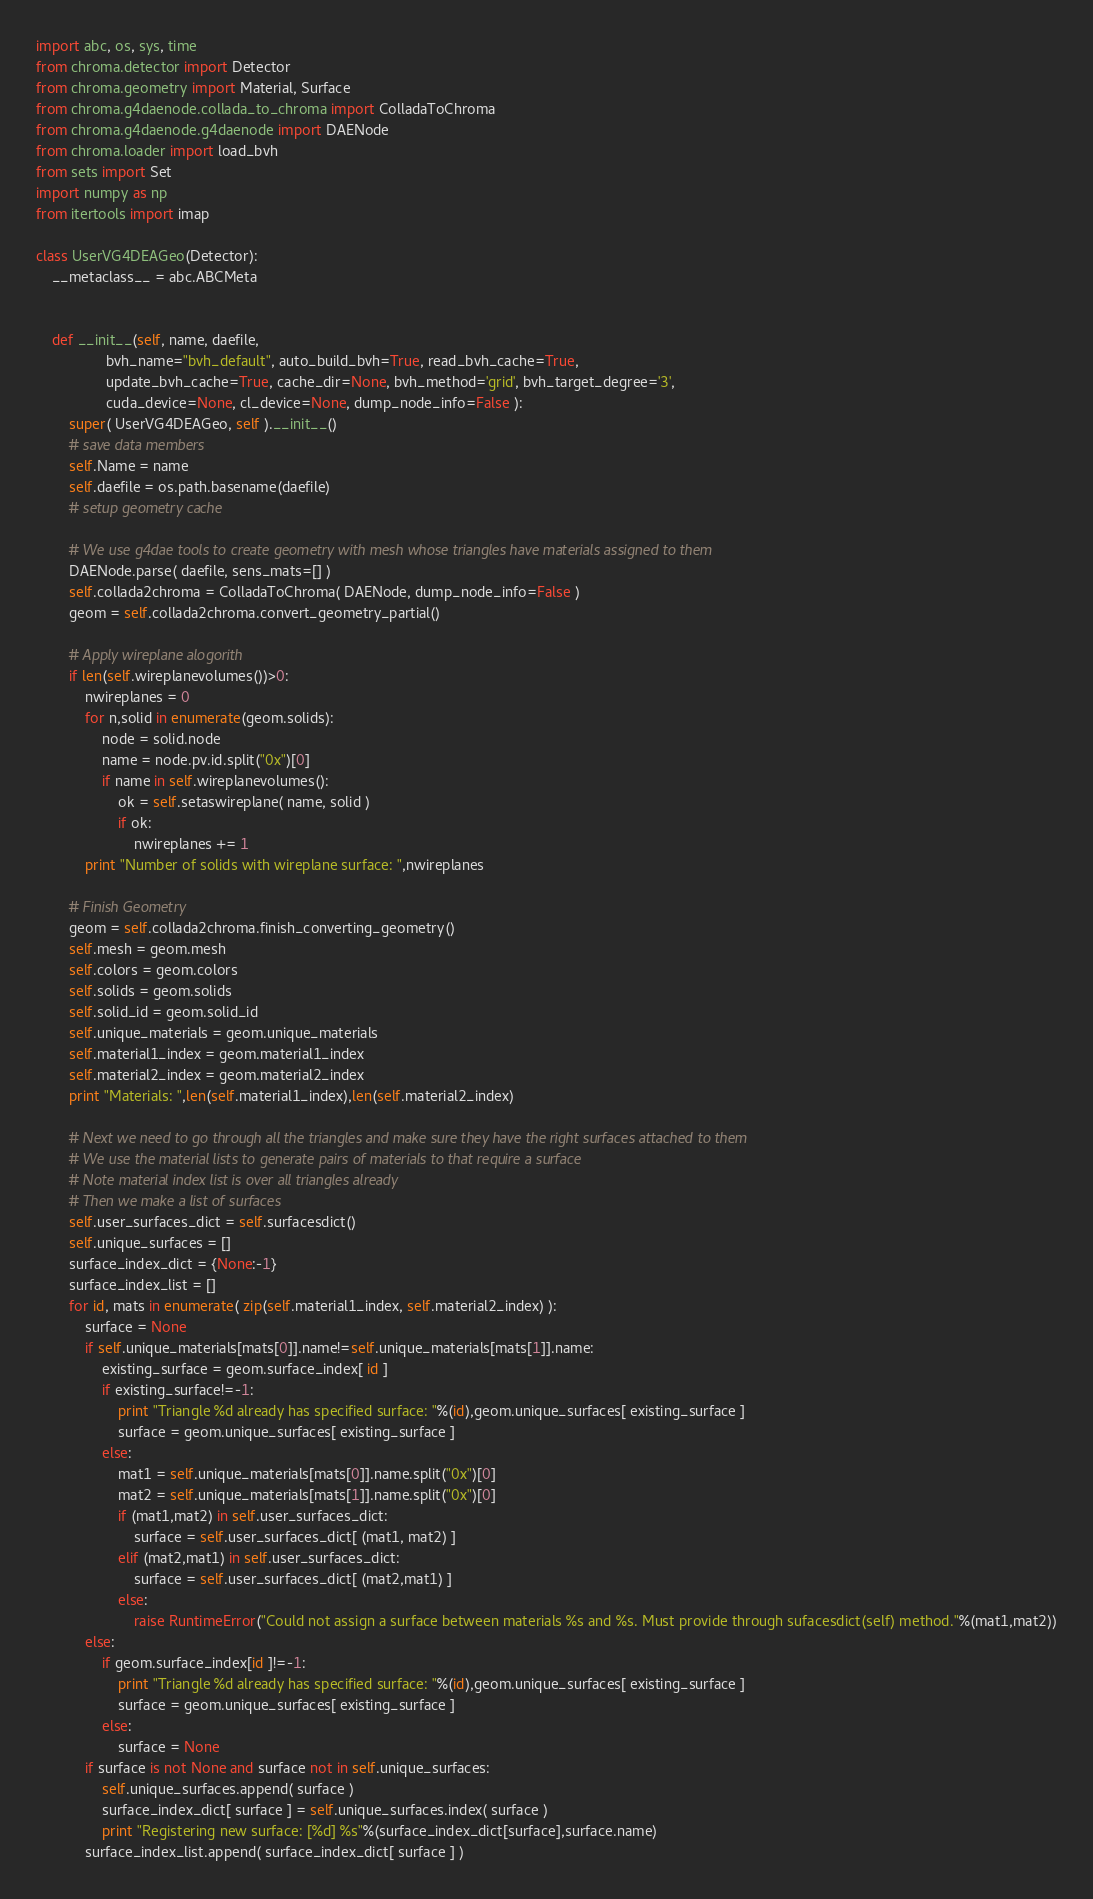<code> <loc_0><loc_0><loc_500><loc_500><_Python_>import abc, os, sys, time
from chroma.detector import Detector
from chroma.geometry import Material, Surface
from chroma.g4daenode.collada_to_chroma import ColladaToChroma
from chroma.g4daenode.g4daenode import DAENode
from chroma.loader import load_bvh
from sets import Set
import numpy as np
from itertools import imap

class UserVG4DEAGeo(Detector):
    __metaclass__ = abc.ABCMeta
    

    def __init__(self, name, daefile,
                 bvh_name="bvh_default", auto_build_bvh=True, read_bvh_cache=True, 
                 update_bvh_cache=True, cache_dir=None, bvh_method='grid', bvh_target_degree='3',
                 cuda_device=None, cl_device=None, dump_node_info=False ):
        super( UserVG4DEAGeo, self ).__init__()
        # save data members
        self.Name = name
        self.daefile = os.path.basename(daefile)
        # setup geometry cache

        # We use g4dae tools to create geometry with mesh whose triangles have materials assigned to them
        DAENode.parse( daefile, sens_mats=[] )
        self.collada2chroma = ColladaToChroma( DAENode, dump_node_info=False )
        geom = self.collada2chroma.convert_geometry_partial()
        
        # Apply wireplane alogorith
        if len(self.wireplanevolumes())>0:
            nwireplanes = 0
            for n,solid in enumerate(geom.solids):
                node = solid.node
                name = node.pv.id.split("0x")[0]
                if name in self.wireplanevolumes():
                    ok = self.setaswireplane( name, solid )
                    if ok:
                        nwireplanes += 1
            print "Number of solids with wireplane surface: ",nwireplanes
        
        # Finish Geometry
        geom = self.collada2chroma.finish_converting_geometry()
        self.mesh = geom.mesh
        self.colors = geom.colors
        self.solids = geom.solids
        self.solid_id = geom.solid_id
        self.unique_materials = geom.unique_materials
        self.material1_index = geom.material1_index
        self.material2_index = geom.material2_index
        print "Materials: ",len(self.material1_index),len(self.material2_index)

        # Next we need to go through all the triangles and make sure they have the right surfaces attached to them
        # We use the material lists to generate pairs of materials to that require a surface
        # Note material index list is over all triangles already
        # Then we make a list of surfaces
        self.user_surfaces_dict = self.surfacesdict()
        self.unique_surfaces = []
        surface_index_dict = {None:-1}
        surface_index_list = []
        for id, mats in enumerate( zip(self.material1_index, self.material2_index) ):
            surface = None
            if self.unique_materials[mats[0]].name!=self.unique_materials[mats[1]].name:
                existing_surface = geom.surface_index[ id ]
                if existing_surface!=-1:
                    print "Triangle %d already has specified surface: "%(id),geom.unique_surfaces[ existing_surface ]
                    surface = geom.unique_surfaces[ existing_surface ]
                else:
                    mat1 = self.unique_materials[mats[0]].name.split("0x")[0]
                    mat2 = self.unique_materials[mats[1]].name.split("0x")[0]
                    if (mat1,mat2) in self.user_surfaces_dict:
                        surface = self.user_surfaces_dict[ (mat1, mat2) ]
                    elif (mat2,mat1) in self.user_surfaces_dict:
                        surface = self.user_surfaces_dict[ (mat2,mat1) ]
                    else:
                        raise RuntimeError("Could not assign a surface between materials %s and %s. Must provide through sufacesdict(self) method."%(mat1,mat2))
            else:
                if geom.surface_index[id ]!=-1:
                    print "Triangle %d already has specified surface: "%(id),geom.unique_surfaces[ existing_surface ]
                    surface = geom.unique_surfaces[ existing_surface ]
                else:
                    surface = None
            if surface is not None and surface not in self.unique_surfaces:
                self.unique_surfaces.append( surface )
                surface_index_dict[ surface ] = self.unique_surfaces.index( surface )
                print "Registering new surface: [%d] %s"%(surface_index_dict[surface],surface.name)
            surface_index_list.append( surface_index_dict[ surface ] )
</code> 